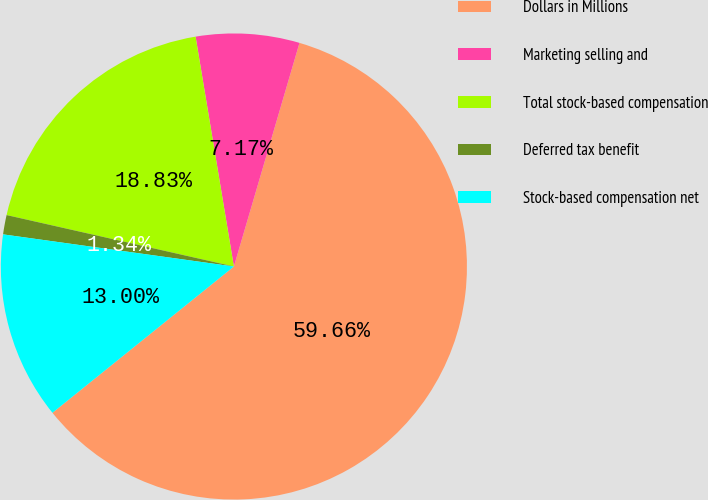Convert chart to OTSL. <chart><loc_0><loc_0><loc_500><loc_500><pie_chart><fcel>Dollars in Millions<fcel>Marketing selling and<fcel>Total stock-based compensation<fcel>Deferred tax benefit<fcel>Stock-based compensation net<nl><fcel>59.66%<fcel>7.17%<fcel>18.83%<fcel>1.34%<fcel>13.0%<nl></chart> 